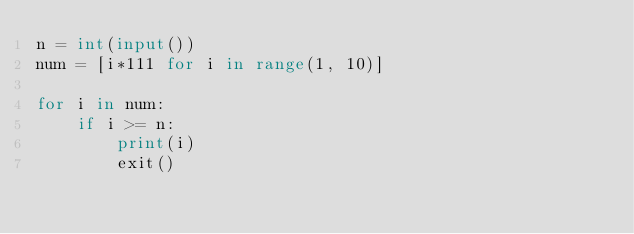<code> <loc_0><loc_0><loc_500><loc_500><_Python_>n = int(input())
num = [i*111 for i in range(1, 10)]

for i in num:
    if i >= n:
        print(i)
        exit()</code> 